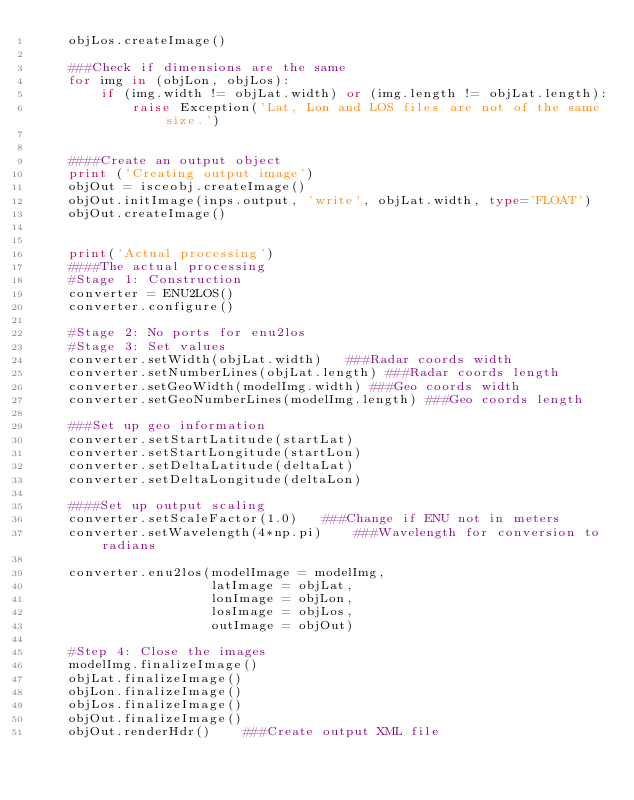Convert code to text. <code><loc_0><loc_0><loc_500><loc_500><_Python_>    objLos.createImage()
    
    ###Check if dimensions are the same
    for img in (objLon, objLos):
        if (img.width != objLat.width) or (img.length != objLat.length):
            raise Exception('Lat, Lon and LOS files are not of the same size.')
            
    
    ####Create an output object
    print ('Creating output image')
    objOut = isceobj.createImage()
    objOut.initImage(inps.output, 'write', objLat.width, type='FLOAT')
    objOut.createImage()
    
    
    print('Actual processing')
    ####The actual processing
    #Stage 1: Construction
    converter = ENU2LOS()
    converter.configure()
    
    #Stage 2: No ports for enu2los
    #Stage 3: Set values 
    converter.setWidth(objLat.width)   ###Radar coords width
    converter.setNumberLines(objLat.length) ###Radar coords length
    converter.setGeoWidth(modelImg.width) ###Geo coords width
    converter.setGeoNumberLines(modelImg.length) ###Geo coords length
    
    ###Set up geo information
    converter.setStartLatitude(startLat)
    converter.setStartLongitude(startLon)
    converter.setDeltaLatitude(deltaLat)
    converter.setDeltaLongitude(deltaLon)
    
    ####Set up output scaling
    converter.setScaleFactor(1.0)   ###Change if ENU not in meters
    converter.setWavelength(4*np.pi)    ###Wavelength for conversion to radians
    
    converter.enu2los(modelImage = modelImg,
                      latImage = objLat,
                      lonImage = objLon,
                      losImage = objLos,
                      outImage = objOut)
                      
    #Step 4: Close the images
    modelImg.finalizeImage()
    objLat.finalizeImage()
    objLon.finalizeImage()
    objLos.finalizeImage()
    objOut.finalizeImage()
    objOut.renderHdr()    ###Create output XML file

</code> 